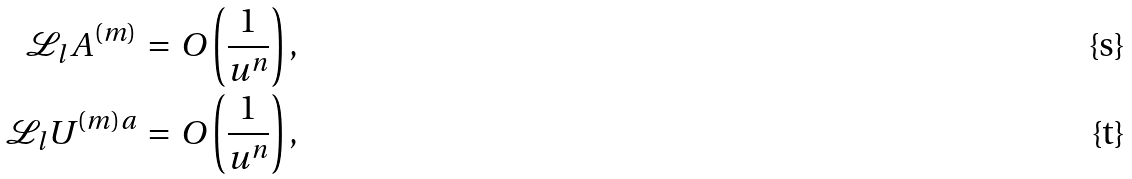Convert formula to latex. <formula><loc_0><loc_0><loc_500><loc_500>\mathcal { L } _ { l } A ^ { ( m ) } \, = \, O \left ( \frac { 1 } { u ^ { n } } \right ) , \\ \mathcal { L } _ { l } U ^ { ( m ) a } \, = \, O \left ( \frac { 1 } { u ^ { n } } \right ) ,</formula> 